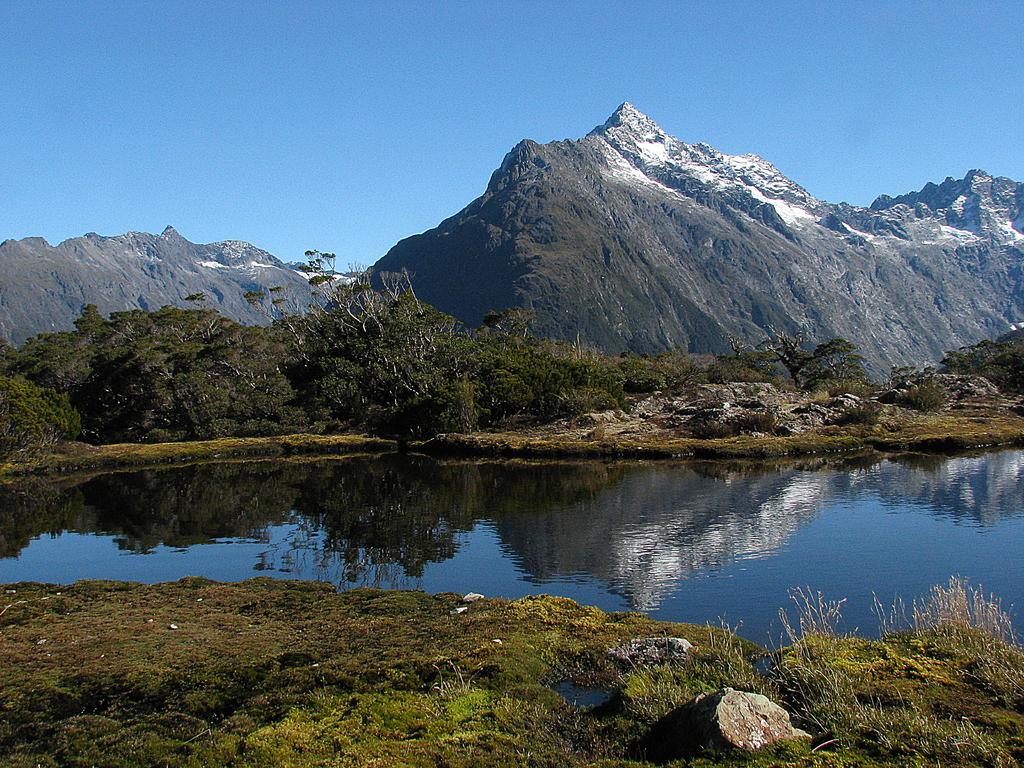What type of vegetation can be seen in the image? There is grass in the image. What natural element is also present in the image? There is water in the image. What other type of vegetation is visible in the image? There are trees in the image. What can be seen in the distance in the background of the image? There are mountains visible in the background of the image. What is the condition of the sky in the image? The sky is clear in the image. What color is the error message displayed on the grass in the image? There is no error message present in the image; it is a natural scene featuring grass, water, trees, mountains, and a clear sky. 